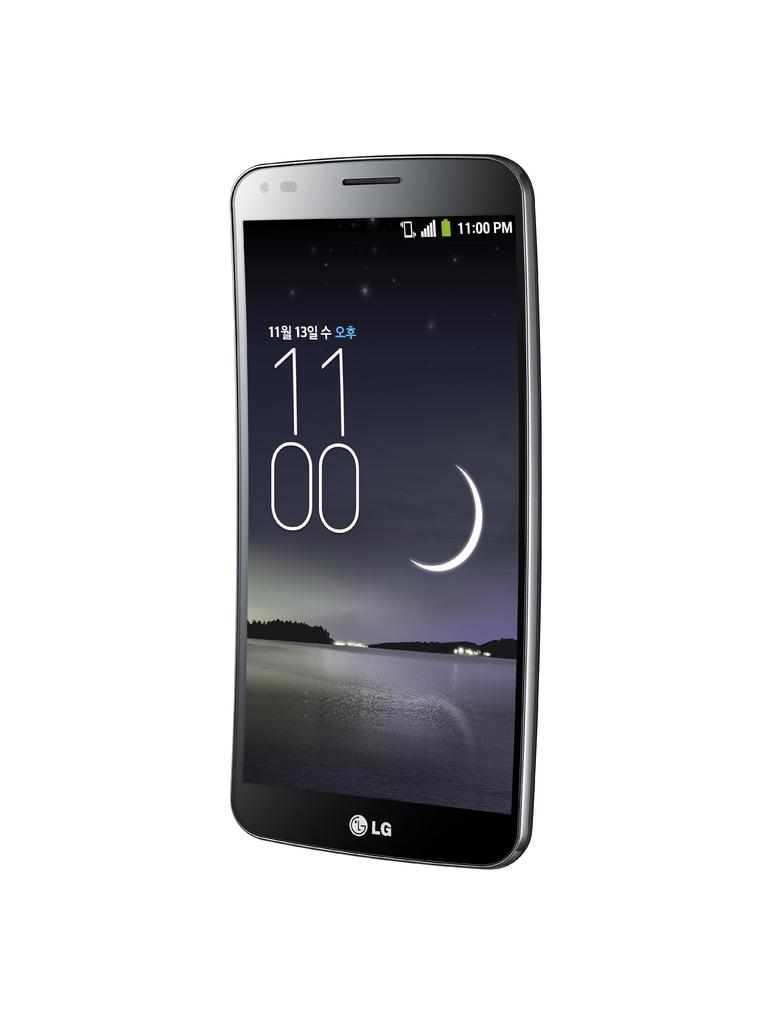What time is shown on the phone?
Provide a short and direct response. 11:00. 